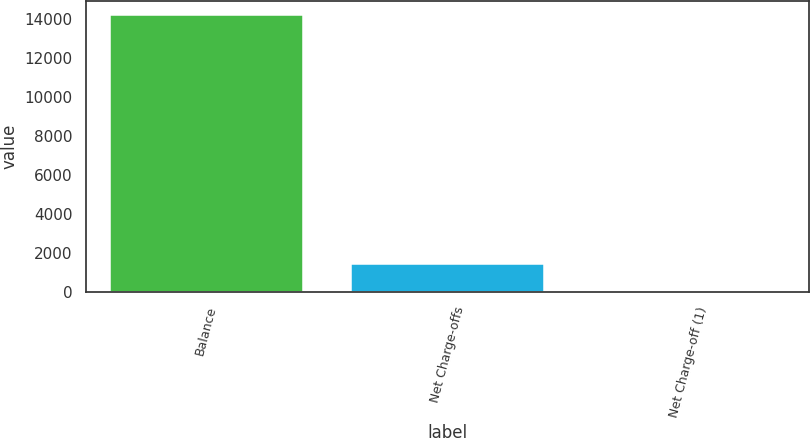<chart> <loc_0><loc_0><loc_500><loc_500><bar_chart><fcel>Balance<fcel>Net Charge-offs<fcel>Net Charge-off (1)<nl><fcel>14226<fcel>1425.12<fcel>2.8<nl></chart> 